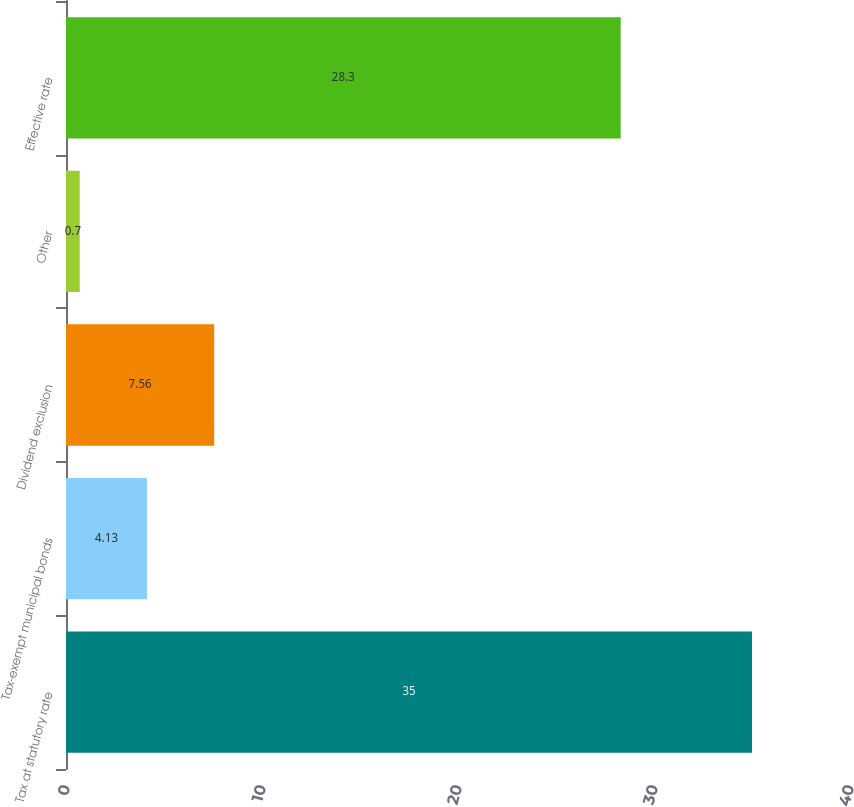<chart> <loc_0><loc_0><loc_500><loc_500><bar_chart><fcel>Tax at statutory rate<fcel>Tax-exempt municipal bonds<fcel>Dividend exclusion<fcel>Other<fcel>Effective rate<nl><fcel>35<fcel>4.13<fcel>7.56<fcel>0.7<fcel>28.3<nl></chart> 